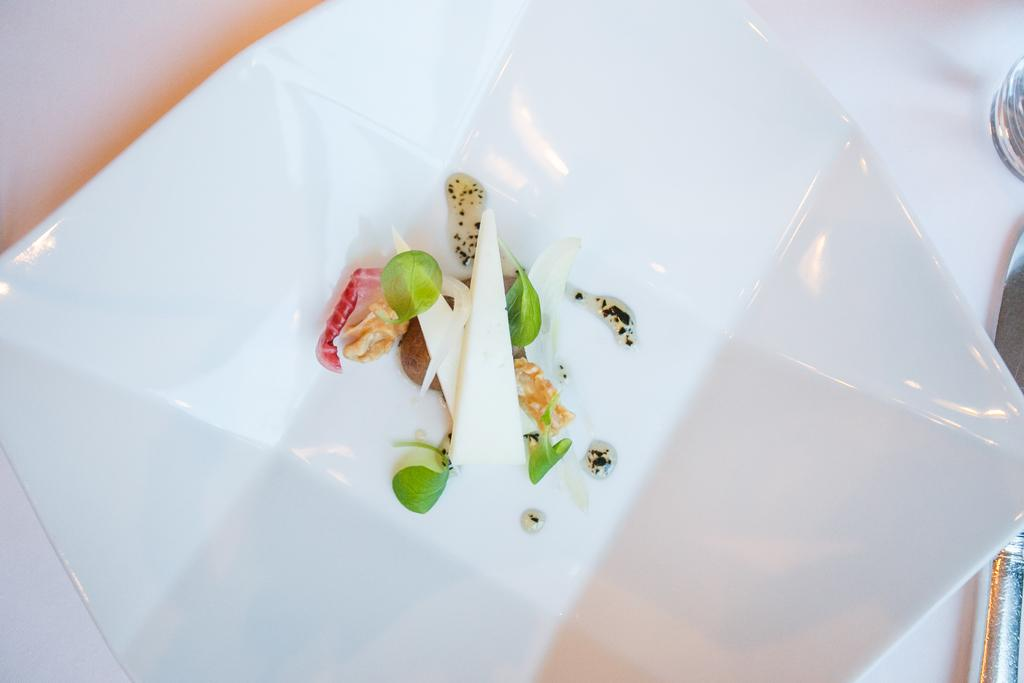What is in the center of the image? There are food items in a plate in the center of the image. What is located at the bottom of the image? There is a table at the bottom of the image. What utensil can be seen in the image? There is a knife present. What type of structure is visible in the yard in the image? There is no yard or structure present in the image. 